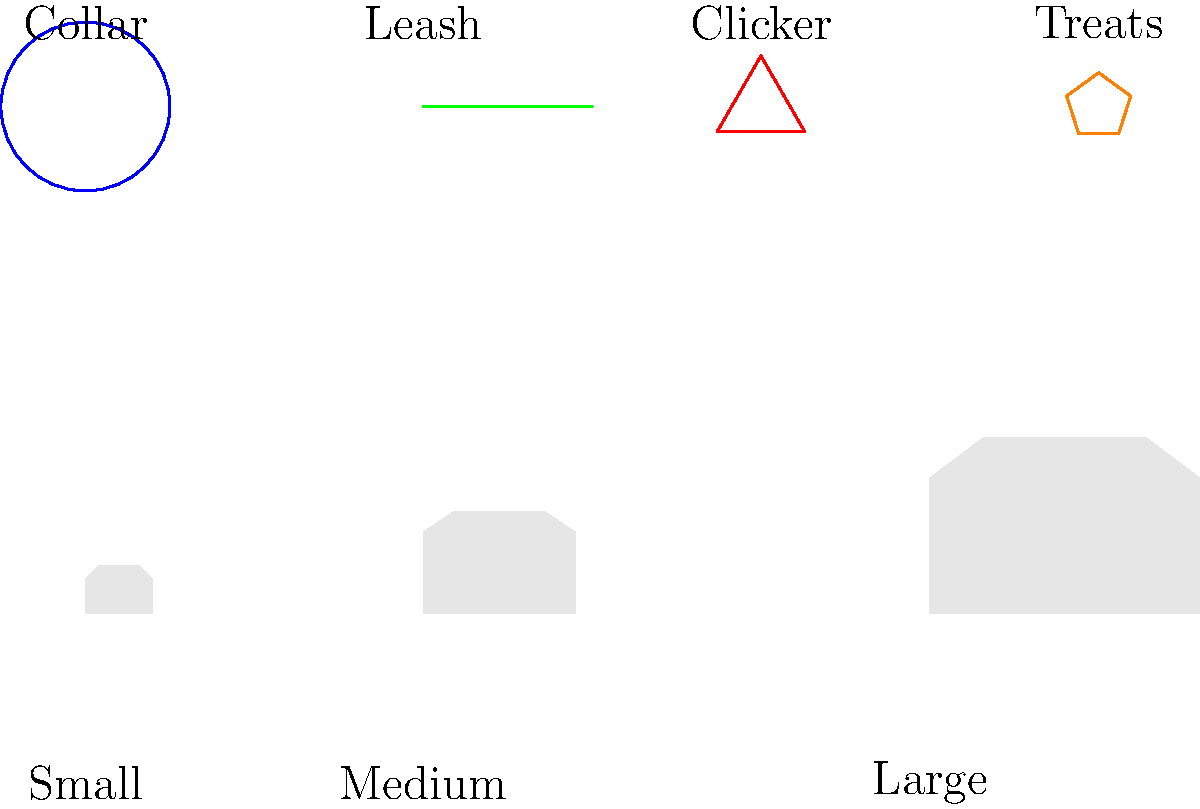Which training tool would be most effective for initial obedience training across all puppy sizes, considering the varying physical characteristics and learning styles of different breeds? To determine the most effective training tool for initial obedience training across all puppy sizes, let's consider each option:

1. Collar: While essential for identification and control, it's not primarily a training tool for obedience.

2. Leash: Important for control and outdoor training, but not the most effective for initial obedience training indoors.

3. Clicker: An excellent tool for precise timing and marking desired behaviors, but it requires proper technique and may not be suitable for all breeds or trainers.

4. Treats: High-value rewards are universally effective for positive reinforcement across all breed sizes and types.

Treats offer several advantages for initial obedience training:
a) They work for all sizes of puppies, from small to large breeds.
b) They provide immediate positive reinforcement, which is crucial for puppies' learning.
c) They can be easily adapted in size and type to suit different breeds' preferences and dietary needs.
d) Treats can be used in conjunction with other training methods, making them versatile.
e) They help create a positive association with training, which is essential for long-term success.

While all tools have their place in a comprehensive training program, treats are the most universally effective for initial obedience training across all puppy sizes and breeds.
Answer: Treats 